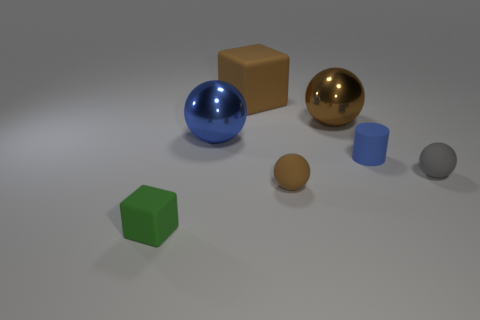Are there any small cylinders?
Offer a terse response. Yes. Is the number of small gray spheres the same as the number of tiny yellow metallic cylinders?
Your answer should be compact. No. How many large matte things have the same color as the matte cylinder?
Offer a very short reply. 0. Are the blue cylinder and the large object that is left of the brown cube made of the same material?
Provide a short and direct response. No. Is the number of blue matte things that are in front of the tiny gray matte sphere greater than the number of tiny blue cylinders?
Your answer should be very brief. No. Is there anything else that has the same size as the green rubber thing?
Give a very brief answer. Yes. There is a small rubber cylinder; does it have the same color as the rubber object that is in front of the small brown matte ball?
Make the answer very short. No. Are there an equal number of gray rubber balls that are on the left side of the tiny green matte object and brown cubes that are in front of the brown metallic object?
Give a very brief answer. Yes. What is the material of the tiny thing that is behind the small gray sphere?
Keep it short and to the point. Rubber. What number of things are blocks behind the tiny gray rubber ball or tiny brown rubber blocks?
Your response must be concise. 1. 